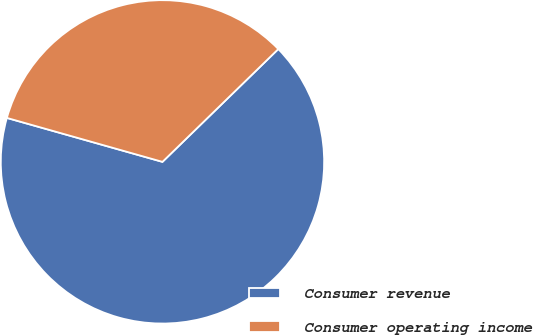Convert chart. <chart><loc_0><loc_0><loc_500><loc_500><pie_chart><fcel>Consumer revenue<fcel>Consumer operating income<nl><fcel>66.67%<fcel>33.33%<nl></chart> 